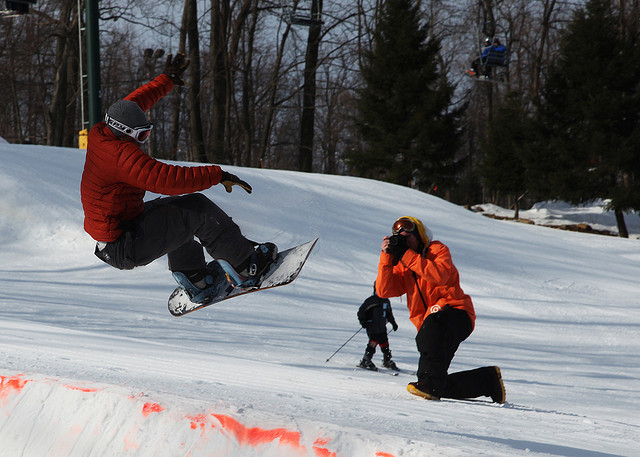<image>Why is the orange line on the surface? The reason why there is an orange line on the surface is unknown. It could potentially be paint or a boundary line for a sport like snowboarding. Why is the orange line on the surface? I don't know why the orange line is on the surface. It can be for painting, snowboarding or boundary marking. 